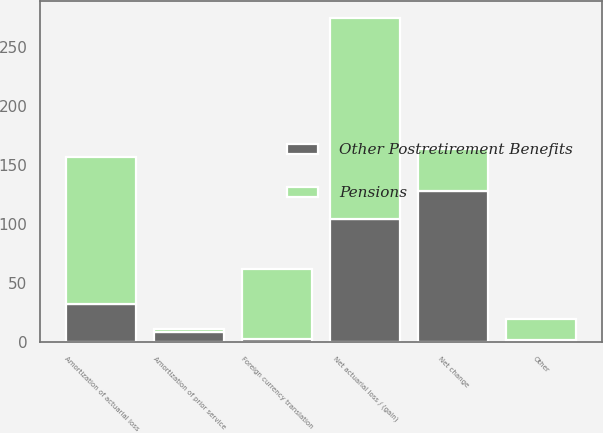Convert chart. <chart><loc_0><loc_0><loc_500><loc_500><stacked_bar_chart><ecel><fcel>Net actuarial loss / (gain)<fcel>Amortization of actuarial loss<fcel>Amortization of prior service<fcel>Foreign currency translation<fcel>Other<fcel>Net change<nl><fcel>Pensions<fcel>171<fcel>125<fcel>2<fcel>59<fcel>18<fcel>36<nl><fcel>Other Postretirement Benefits<fcel>104<fcel>32<fcel>9<fcel>3<fcel>2<fcel>128<nl></chart> 